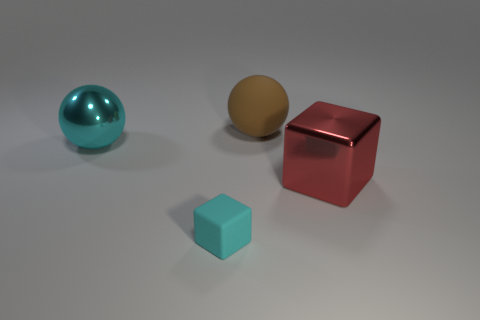Add 1 large red things. How many objects exist? 5 Subtract all rubber cubes. Subtract all matte cylinders. How many objects are left? 3 Add 2 big things. How many big things are left? 5 Add 3 brown matte objects. How many brown matte objects exist? 4 Subtract 0 blue blocks. How many objects are left? 4 